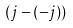<formula> <loc_0><loc_0><loc_500><loc_500>( j - ( - j ) )</formula> 